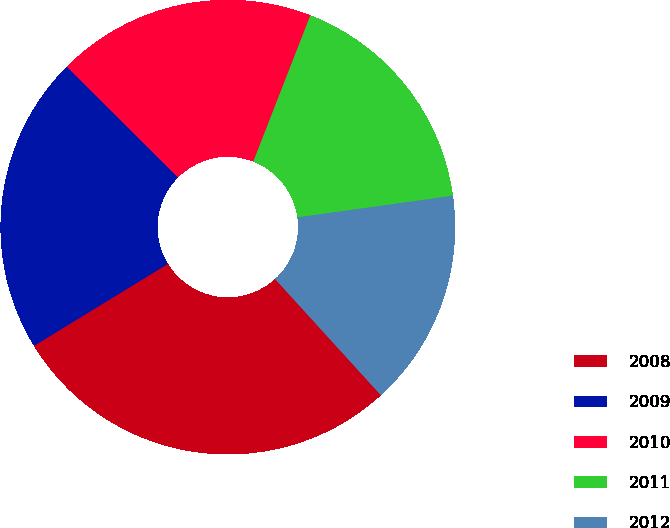Convert chart to OTSL. <chart><loc_0><loc_0><loc_500><loc_500><pie_chart><fcel>2008<fcel>2009<fcel>2010<fcel>2011<fcel>2012<nl><fcel>28.01%<fcel>21.22%<fcel>18.45%<fcel>16.88%<fcel>15.44%<nl></chart> 